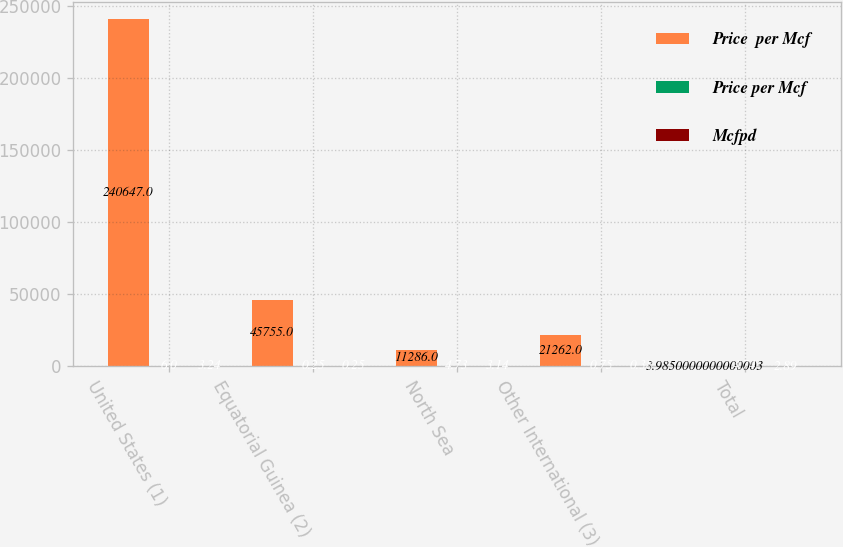<chart> <loc_0><loc_0><loc_500><loc_500><stacked_bar_chart><ecel><fcel>United States (1)<fcel>Equatorial Guinea (2)<fcel>North Sea<fcel>Other International (3)<fcel>Total<nl><fcel>Price  per Mcf<fcel>240647<fcel>45755<fcel>11286<fcel>21262<fcel>3.985<nl><fcel>Price per Mcf<fcel>6<fcel>0.25<fcel>4.73<fcel>0.75<fcel>4.74<nl><fcel>Mcfpd<fcel>3.24<fcel>0.25<fcel>3.14<fcel>0.38<fcel>2.89<nl></chart> 